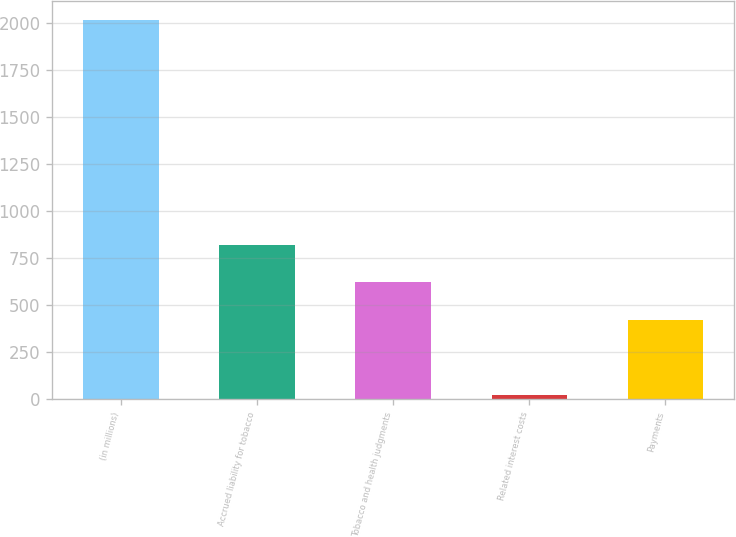<chart> <loc_0><loc_0><loc_500><loc_500><bar_chart><fcel>(in millions)<fcel>Accrued liability for tobacco<fcel>Tobacco and health judgments<fcel>Related interest costs<fcel>Payments<nl><fcel>2015<fcel>819.8<fcel>620.6<fcel>23<fcel>421.4<nl></chart> 